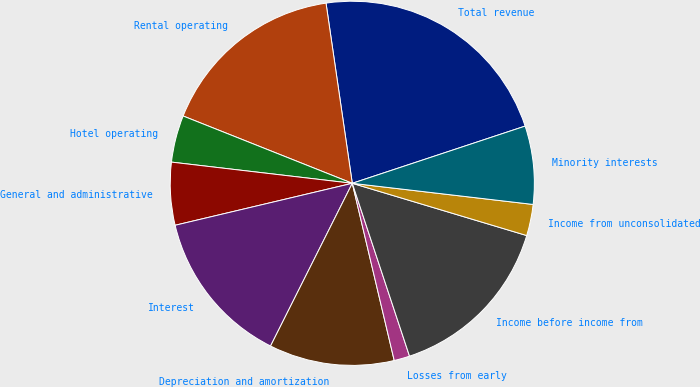Convert chart. <chart><loc_0><loc_0><loc_500><loc_500><pie_chart><fcel>Total revenue<fcel>Rental operating<fcel>Hotel operating<fcel>General and administrative<fcel>Interest<fcel>Depreciation and amortization<fcel>Losses from early<fcel>Income before income from<fcel>Income from unconsolidated<fcel>Minority interests<nl><fcel>22.22%<fcel>16.67%<fcel>4.17%<fcel>5.56%<fcel>13.89%<fcel>11.11%<fcel>1.39%<fcel>15.28%<fcel>2.78%<fcel>6.94%<nl></chart> 